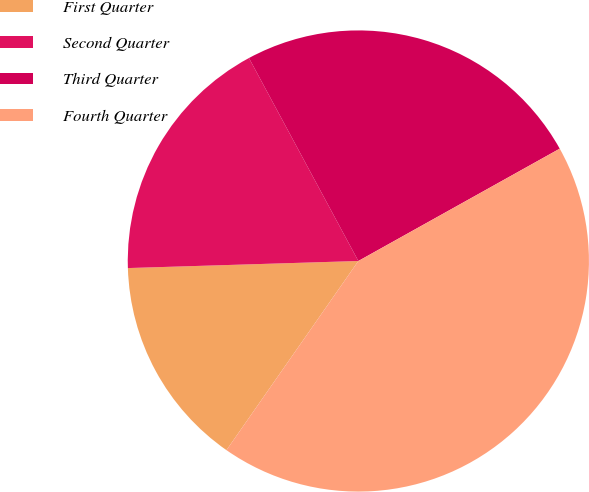<chart> <loc_0><loc_0><loc_500><loc_500><pie_chart><fcel>First Quarter<fcel>Second Quarter<fcel>Third Quarter<fcel>Fourth Quarter<nl><fcel>14.82%<fcel>17.62%<fcel>24.77%<fcel>42.79%<nl></chart> 